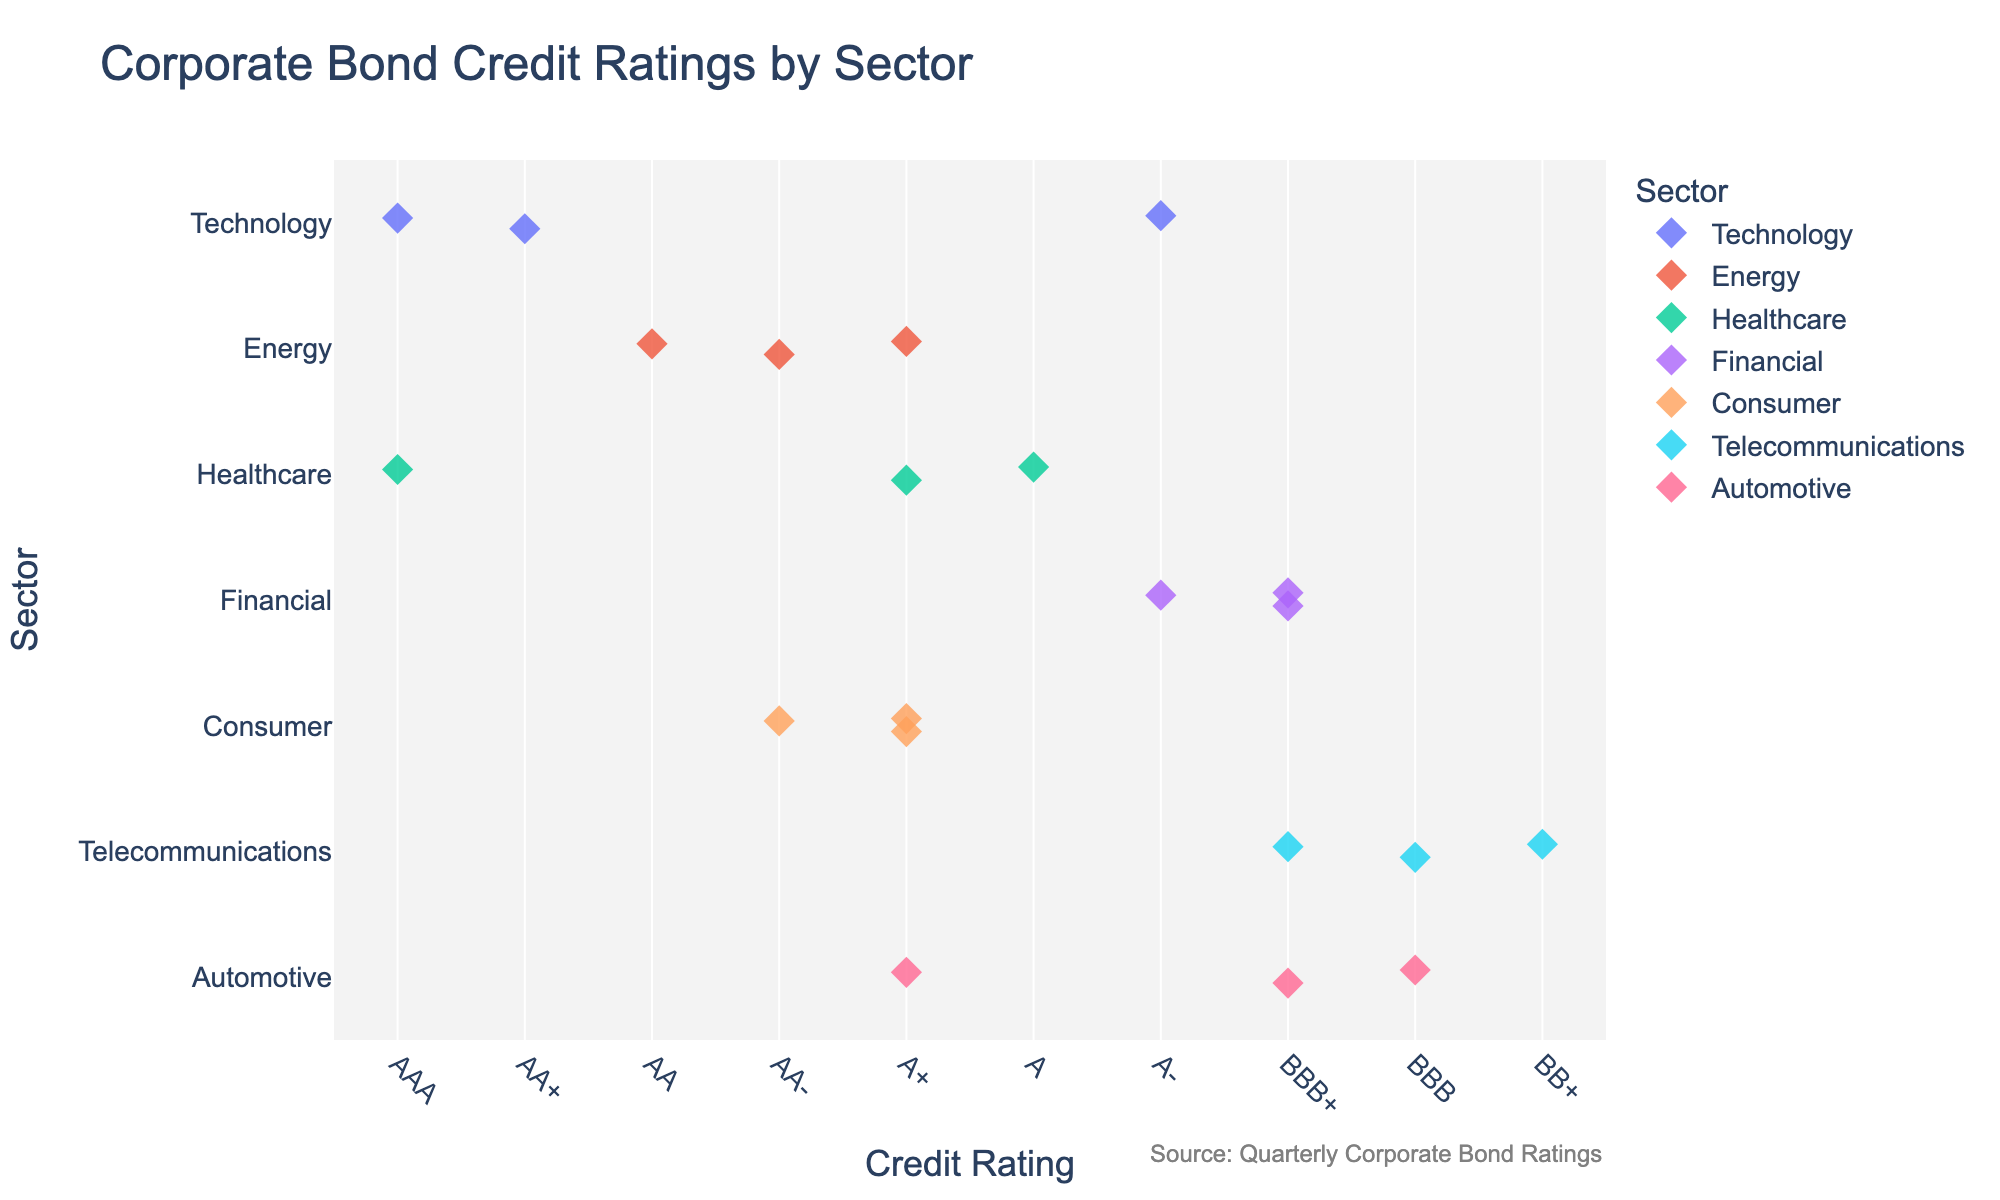Which sector has the highest credit rating on the plot? The highest credit rating is "AAA". Of all the sectors shown in the plot, the 'Healthcare' sector has companies (Johnson & Johnson) with "AAA" ratings.
Answer: Healthcare How many companies in the 'Financial' sector have a credit rating of 'BBB+'? By visually inspecting the plot, the 'Financial' sector includes 'Goldman Sachs' and 'Morgan Stanley', both with a credit rating of 'BBB+'. Therefore, there are 2 companies with 'BBB+' ratings.
Answer: 2 What is the median credit rating for the 'Technology' sector? Credit ratings for 'Technology' are: 'AA+', 'AAA', 'A-'. Converting these to their numeric equivalents (2, 1, 7) and finding the median, the middle value in the sorted list [1, 2, 7] is '2', which corresponds to 'AA+'.
Answer: AA+ Which sector contains the company with the lowest credit rating? The lowest credit rating in the plot is 'BB+', which corresponds to 'T-Mobile' in the 'Telecommunications' sector.
Answer: Telecommunications How many unique credit ratings are present for the 'Consumer' sector? The 'Consumer' sector includes Procter & Gamble (AA-), Coca-Cola (A+), and PepsiCo (A+). There are 2 unique credit ratings: 'AA-' and 'A+'.
Answer: 2 Which company in the 'Automotive' sector has the highest credit rating, and what is that rating? The companies in the 'Automotive' sector are 'Toyota', 'Volkswagen', and 'General Motors'. 'Toyota' has the highest rating of 'A+'.
Answer: Toyota, A+ Are there more companies with a credit rating of 'A+' or 'BBB+' across all sectors? By counting the points on the plot with ratings 'A+' and 'BBB+', there are 5 companies ('Shell', 'Pfizer', 'Coca-Cola', 'PepsiCo', and 'Toyota') with 'A+' and 3 companies ('Goldman Sachs', 'Morgan Stanley', and 'Verizon') with 'BBB+'.
Answer: A+ Which sector has the most diverse range of credit ratings? To determine the sector with the most diverse range of ratings, we need to count the number of unique ratings per sector. The 'Technology' sector has 'AA+', 'AAA', and 'A-'; the 'Energy' sector has four distinct ratings; 'Healthcare' sector has two; 'Financial' sector has three; 'Consumer' sector has two; 'Telecommunications' sector has three; 'Automotive' sector has three. Thus, 'Energy' has the most diverse range of ratings.
Answer: Energy What is the average credit rating (numeric) in the 'Telecommunications' sector? The 'Telecommunications' sector includes 'Verizon' (BBB+ = 8), 'AT&T' (BBB = 9), and 'T-Mobile' (BB+ = 10). The average rating is (8 + 9 + 10) / 3 = 9.
Answer: 9 How does the median rating in 'Consumer' compare to that in 'Healthcare'? For 'Consumer', the ratings are 'AA-', 'A+', 'A+' which convert to (4, 5, 5). Median for 'Consumer' = 5 ('A+'). For 'Healthcare', the ratings are 'AAA', 'A+', 'A' which convert to (1, 5, 6). Median for Healthcare = 5 ('A+'). Both medians are identical, at 'A+'.
Answer: Same (A+) 